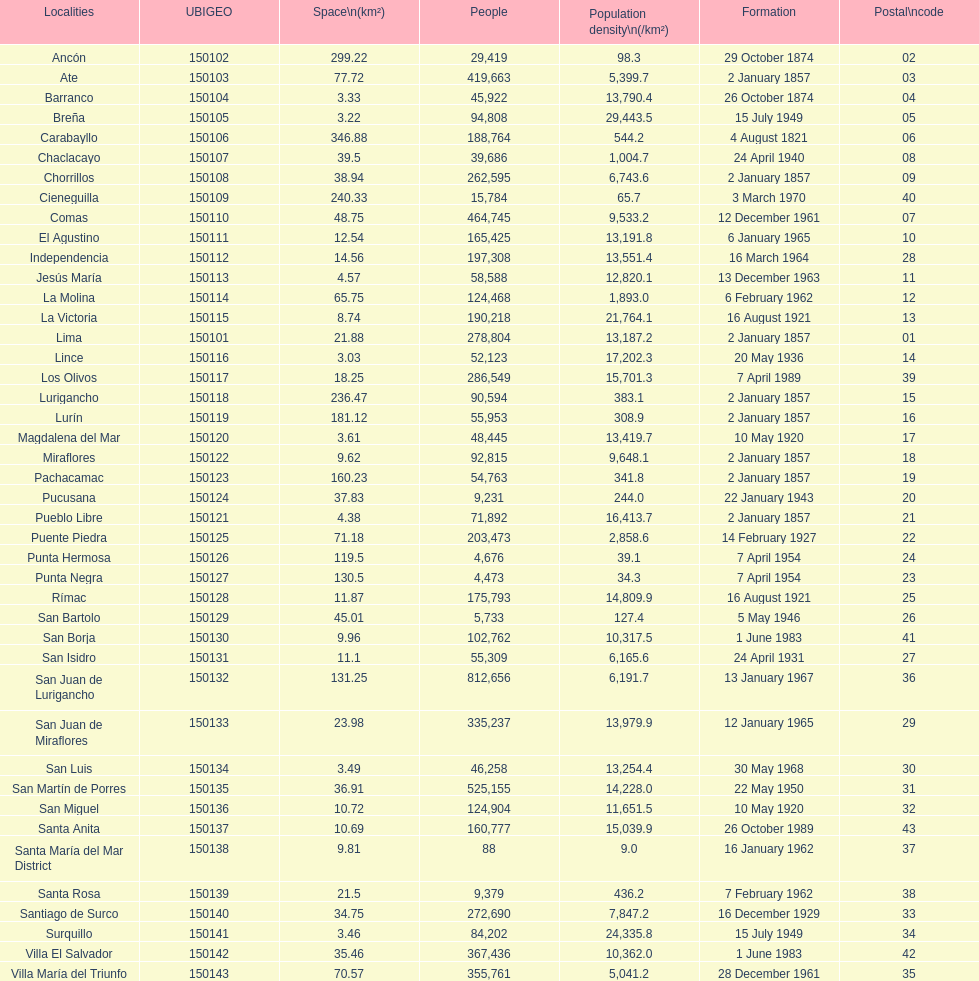Which is the largest district in terms of population? San Juan de Lurigancho. 